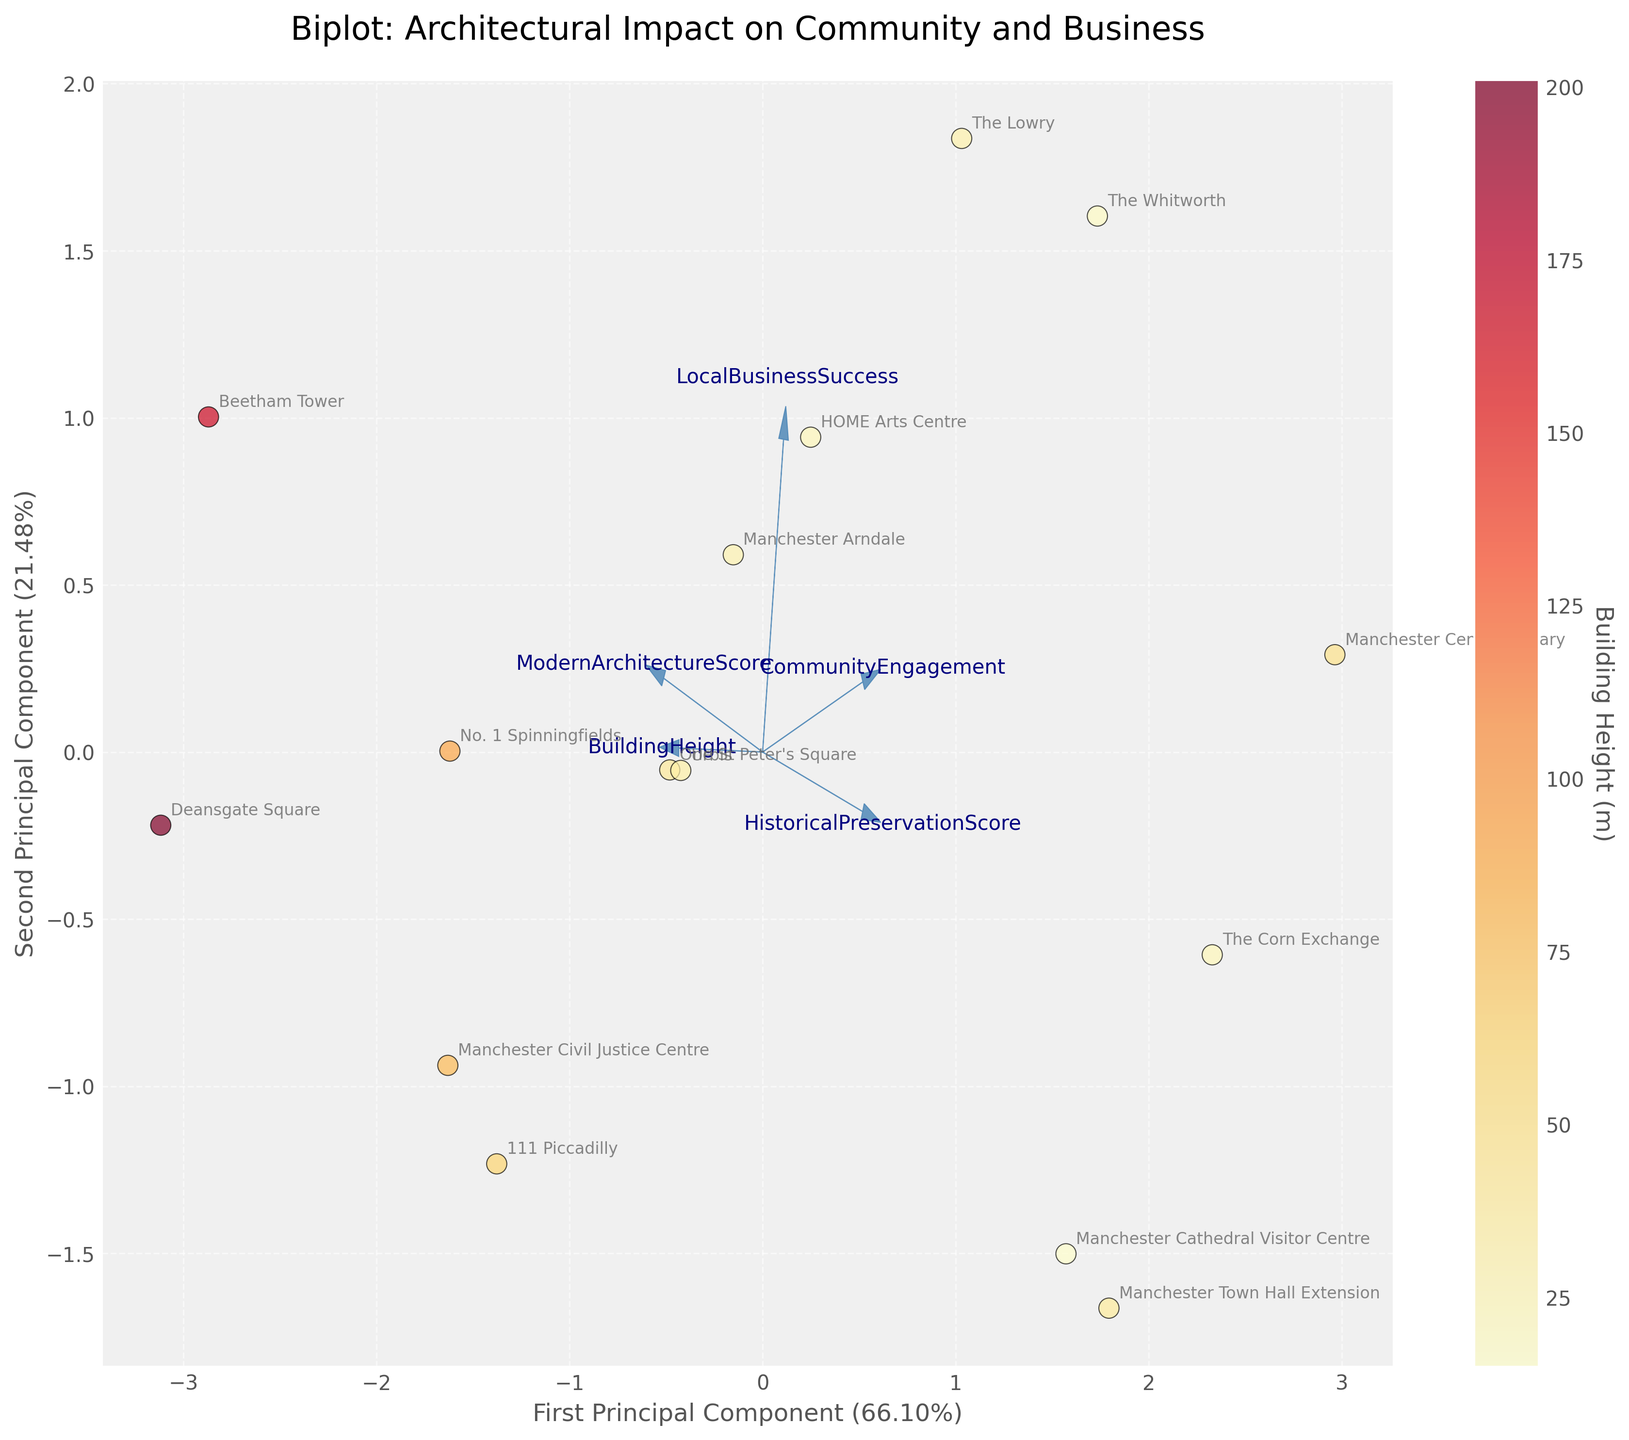How many projects are plotted on the biplot? Count the number of labeled data points in the plot.
Answer: 15 What is the title of the biplot? Look at the top of the figure where the title is usually displayed.
Answer: Biplot: Architectural Impact on Community and Business Which project has the highest Building Height according to the color bar? Look for the data point with the darkest color (indicating the highest value) and match it with the project's name.
Answer: Deansgate Square Which feature has the longest vector in the biplot? Observe the arrows representing the features and identify the longest one.
Answer: BuildingHeight Do projects with higher Historical Preservation Scores tend to have higher Community Engagement scores? Compare the positions of data points with high Historical Preservation Scores to their Community Engagement scores.
Answer: Yes, mostly Which project is the furthest away from the origin in the positive direction of the first principal component? Look at the data points plotted furthest to the right on the horizontal axis.
Answer: Beetham Tower How does the Community Engagement vector align relative to the Local Business Success vector? Analyze the angles and directions of the Community Engagement and Local Business Success vectors.
Answer: They're positively correlated and oriented similarly Which data points are closely located together indicating similar characteristics? Observe clusters of data points that are positioned near each other.
Answer: The Lowry and The Whitworth What is the primary contributor to the first principal component? Look at the vectors pointing in the direction of the first principal component and identify the dominant one.
Answer: BuildingHeight Which project is almost on the origin, indicating minimal variation in all standardized features? Identify the data point situated very close to the origin of the biplot.
Answer: Manchester Town Hall Extension 